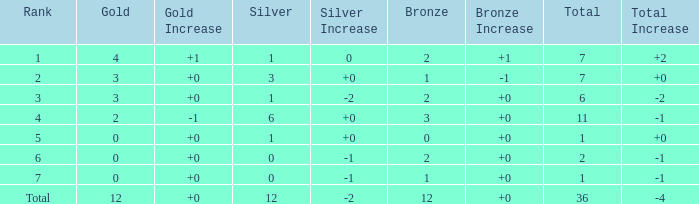What is the largest total for a team with fewer than 12 bronze, 1 silver and 0 gold medals? 1.0. 